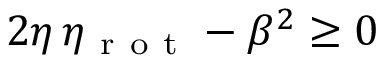<formula> <loc_0><loc_0><loc_500><loc_500>2 \eta \, \eta _ { r o t } - \beta ^ { 2 } \geq 0</formula> 